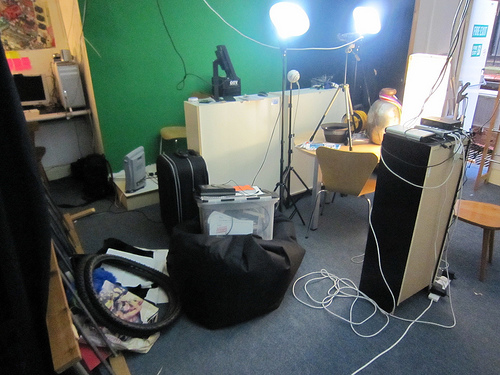<image>
Is there a wire on the floor? Yes. Looking at the image, I can see the wire is positioned on top of the floor, with the floor providing support. 